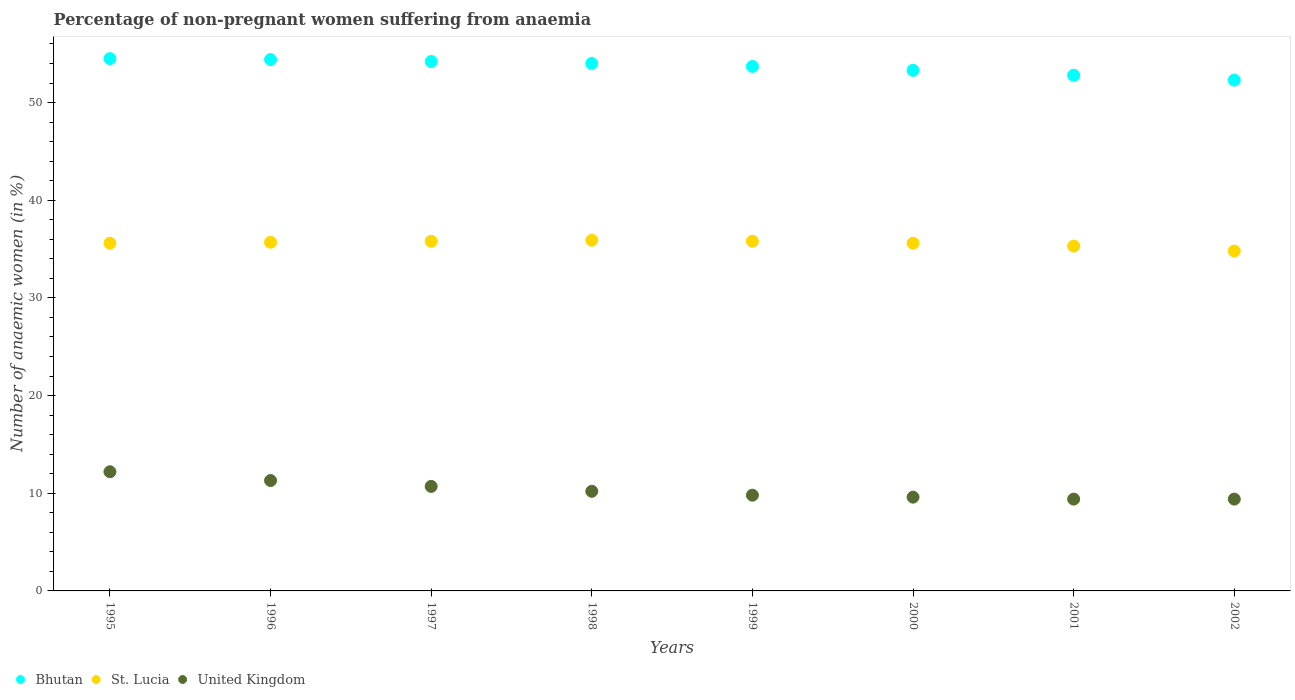What is the percentage of non-pregnant women suffering from anaemia in United Kingdom in 1998?
Your response must be concise. 10.2. Across all years, what is the maximum percentage of non-pregnant women suffering from anaemia in United Kingdom?
Your answer should be very brief. 12.2. In which year was the percentage of non-pregnant women suffering from anaemia in Bhutan maximum?
Your response must be concise. 1995. In which year was the percentage of non-pregnant women suffering from anaemia in St. Lucia minimum?
Offer a very short reply. 2002. What is the total percentage of non-pregnant women suffering from anaemia in United Kingdom in the graph?
Offer a very short reply. 82.6. What is the difference between the percentage of non-pregnant women suffering from anaemia in Bhutan in 1996 and that in 2000?
Offer a terse response. 1.1. What is the difference between the percentage of non-pregnant women suffering from anaemia in United Kingdom in 2002 and the percentage of non-pregnant women suffering from anaemia in St. Lucia in 1996?
Provide a short and direct response. -26.3. What is the average percentage of non-pregnant women suffering from anaemia in Bhutan per year?
Your response must be concise. 53.65. What is the ratio of the percentage of non-pregnant women suffering from anaemia in Bhutan in 1996 to that in 1999?
Keep it short and to the point. 1.01. Is the percentage of non-pregnant women suffering from anaemia in Bhutan in 1998 less than that in 2002?
Give a very brief answer. No. What is the difference between the highest and the second highest percentage of non-pregnant women suffering from anaemia in St. Lucia?
Make the answer very short. 0.1. What is the difference between the highest and the lowest percentage of non-pregnant women suffering from anaemia in St. Lucia?
Your answer should be very brief. 1.1. In how many years, is the percentage of non-pregnant women suffering from anaemia in St. Lucia greater than the average percentage of non-pregnant women suffering from anaemia in St. Lucia taken over all years?
Your response must be concise. 6. Does the percentage of non-pregnant women suffering from anaemia in United Kingdom monotonically increase over the years?
Give a very brief answer. No. Is the percentage of non-pregnant women suffering from anaemia in Bhutan strictly less than the percentage of non-pregnant women suffering from anaemia in St. Lucia over the years?
Make the answer very short. No. How many dotlines are there?
Provide a short and direct response. 3. How many years are there in the graph?
Your response must be concise. 8. What is the difference between two consecutive major ticks on the Y-axis?
Provide a succinct answer. 10. Are the values on the major ticks of Y-axis written in scientific E-notation?
Offer a terse response. No. Does the graph contain grids?
Ensure brevity in your answer.  No. How many legend labels are there?
Ensure brevity in your answer.  3. What is the title of the graph?
Your response must be concise. Percentage of non-pregnant women suffering from anaemia. What is the label or title of the Y-axis?
Your response must be concise. Number of anaemic women (in %). What is the Number of anaemic women (in %) in Bhutan in 1995?
Your answer should be compact. 54.5. What is the Number of anaemic women (in %) in St. Lucia in 1995?
Offer a terse response. 35.6. What is the Number of anaemic women (in %) of Bhutan in 1996?
Ensure brevity in your answer.  54.4. What is the Number of anaemic women (in %) of St. Lucia in 1996?
Ensure brevity in your answer.  35.7. What is the Number of anaemic women (in %) of Bhutan in 1997?
Your answer should be very brief. 54.2. What is the Number of anaemic women (in %) of St. Lucia in 1997?
Give a very brief answer. 35.8. What is the Number of anaemic women (in %) of St. Lucia in 1998?
Make the answer very short. 35.9. What is the Number of anaemic women (in %) of Bhutan in 1999?
Your response must be concise. 53.7. What is the Number of anaemic women (in %) of St. Lucia in 1999?
Your answer should be very brief. 35.8. What is the Number of anaemic women (in %) in United Kingdom in 1999?
Give a very brief answer. 9.8. What is the Number of anaemic women (in %) of Bhutan in 2000?
Offer a very short reply. 53.3. What is the Number of anaemic women (in %) of St. Lucia in 2000?
Provide a short and direct response. 35.6. What is the Number of anaemic women (in %) of United Kingdom in 2000?
Ensure brevity in your answer.  9.6. What is the Number of anaemic women (in %) in Bhutan in 2001?
Ensure brevity in your answer.  52.8. What is the Number of anaemic women (in %) of St. Lucia in 2001?
Provide a short and direct response. 35.3. What is the Number of anaemic women (in %) of Bhutan in 2002?
Your answer should be compact. 52.3. What is the Number of anaemic women (in %) of St. Lucia in 2002?
Give a very brief answer. 34.8. Across all years, what is the maximum Number of anaemic women (in %) of Bhutan?
Keep it short and to the point. 54.5. Across all years, what is the maximum Number of anaemic women (in %) of St. Lucia?
Ensure brevity in your answer.  35.9. Across all years, what is the maximum Number of anaemic women (in %) in United Kingdom?
Keep it short and to the point. 12.2. Across all years, what is the minimum Number of anaemic women (in %) in Bhutan?
Your answer should be very brief. 52.3. Across all years, what is the minimum Number of anaemic women (in %) of St. Lucia?
Make the answer very short. 34.8. What is the total Number of anaemic women (in %) in Bhutan in the graph?
Provide a short and direct response. 429.2. What is the total Number of anaemic women (in %) in St. Lucia in the graph?
Keep it short and to the point. 284.5. What is the total Number of anaemic women (in %) of United Kingdom in the graph?
Ensure brevity in your answer.  82.6. What is the difference between the Number of anaemic women (in %) in St. Lucia in 1995 and that in 1996?
Ensure brevity in your answer.  -0.1. What is the difference between the Number of anaemic women (in %) in United Kingdom in 1995 and that in 1996?
Your answer should be compact. 0.9. What is the difference between the Number of anaemic women (in %) of St. Lucia in 1995 and that in 1997?
Offer a very short reply. -0.2. What is the difference between the Number of anaemic women (in %) of United Kingdom in 1995 and that in 1997?
Keep it short and to the point. 1.5. What is the difference between the Number of anaemic women (in %) in Bhutan in 1995 and that in 1998?
Offer a terse response. 0.5. What is the difference between the Number of anaemic women (in %) in St. Lucia in 1995 and that in 1998?
Keep it short and to the point. -0.3. What is the difference between the Number of anaemic women (in %) in Bhutan in 1995 and that in 1999?
Offer a very short reply. 0.8. What is the difference between the Number of anaemic women (in %) of St. Lucia in 1995 and that in 1999?
Provide a succinct answer. -0.2. What is the difference between the Number of anaemic women (in %) of Bhutan in 1995 and that in 2000?
Give a very brief answer. 1.2. What is the difference between the Number of anaemic women (in %) in St. Lucia in 1995 and that in 2000?
Your response must be concise. 0. What is the difference between the Number of anaemic women (in %) in United Kingdom in 1995 and that in 2000?
Keep it short and to the point. 2.6. What is the difference between the Number of anaemic women (in %) of Bhutan in 1995 and that in 2001?
Offer a terse response. 1.7. What is the difference between the Number of anaemic women (in %) in St. Lucia in 1995 and that in 2001?
Provide a short and direct response. 0.3. What is the difference between the Number of anaemic women (in %) of United Kingdom in 1995 and that in 2001?
Ensure brevity in your answer.  2.8. What is the difference between the Number of anaemic women (in %) in Bhutan in 1995 and that in 2002?
Keep it short and to the point. 2.2. What is the difference between the Number of anaemic women (in %) of St. Lucia in 1996 and that in 1997?
Make the answer very short. -0.1. What is the difference between the Number of anaemic women (in %) of Bhutan in 1996 and that in 1998?
Make the answer very short. 0.4. What is the difference between the Number of anaemic women (in %) in St. Lucia in 1996 and that in 1998?
Your response must be concise. -0.2. What is the difference between the Number of anaemic women (in %) of Bhutan in 1996 and that in 1999?
Provide a succinct answer. 0.7. What is the difference between the Number of anaemic women (in %) of United Kingdom in 1996 and that in 1999?
Offer a terse response. 1.5. What is the difference between the Number of anaemic women (in %) of United Kingdom in 1996 and that in 2000?
Keep it short and to the point. 1.7. What is the difference between the Number of anaemic women (in %) of Bhutan in 1996 and that in 2001?
Give a very brief answer. 1.6. What is the difference between the Number of anaemic women (in %) in St. Lucia in 1996 and that in 2001?
Keep it short and to the point. 0.4. What is the difference between the Number of anaemic women (in %) of United Kingdom in 1996 and that in 2002?
Ensure brevity in your answer.  1.9. What is the difference between the Number of anaemic women (in %) in United Kingdom in 1997 and that in 1998?
Offer a very short reply. 0.5. What is the difference between the Number of anaemic women (in %) in St. Lucia in 1997 and that in 1999?
Make the answer very short. 0. What is the difference between the Number of anaemic women (in %) in United Kingdom in 1997 and that in 1999?
Give a very brief answer. 0.9. What is the difference between the Number of anaemic women (in %) in Bhutan in 1997 and that in 2000?
Give a very brief answer. 0.9. What is the difference between the Number of anaemic women (in %) of United Kingdom in 1997 and that in 2001?
Provide a short and direct response. 1.3. What is the difference between the Number of anaemic women (in %) in Bhutan in 1997 and that in 2002?
Offer a terse response. 1.9. What is the difference between the Number of anaemic women (in %) of United Kingdom in 1997 and that in 2002?
Offer a terse response. 1.3. What is the difference between the Number of anaemic women (in %) of United Kingdom in 1998 and that in 2001?
Your answer should be compact. 0.8. What is the difference between the Number of anaemic women (in %) of Bhutan in 1999 and that in 2000?
Provide a short and direct response. 0.4. What is the difference between the Number of anaemic women (in %) of St. Lucia in 1999 and that in 2000?
Your response must be concise. 0.2. What is the difference between the Number of anaemic women (in %) of United Kingdom in 1999 and that in 2000?
Your answer should be very brief. 0.2. What is the difference between the Number of anaemic women (in %) of United Kingdom in 1999 and that in 2002?
Provide a succinct answer. 0.4. What is the difference between the Number of anaemic women (in %) of Bhutan in 2000 and that in 2001?
Keep it short and to the point. 0.5. What is the difference between the Number of anaemic women (in %) of St. Lucia in 2000 and that in 2001?
Provide a short and direct response. 0.3. What is the difference between the Number of anaemic women (in %) of United Kingdom in 2000 and that in 2001?
Offer a terse response. 0.2. What is the difference between the Number of anaemic women (in %) of United Kingdom in 2000 and that in 2002?
Your answer should be very brief. 0.2. What is the difference between the Number of anaemic women (in %) of St. Lucia in 2001 and that in 2002?
Your answer should be very brief. 0.5. What is the difference between the Number of anaemic women (in %) of United Kingdom in 2001 and that in 2002?
Your answer should be compact. 0. What is the difference between the Number of anaemic women (in %) of Bhutan in 1995 and the Number of anaemic women (in %) of United Kingdom in 1996?
Give a very brief answer. 43.2. What is the difference between the Number of anaemic women (in %) in St. Lucia in 1995 and the Number of anaemic women (in %) in United Kingdom in 1996?
Your answer should be very brief. 24.3. What is the difference between the Number of anaemic women (in %) in Bhutan in 1995 and the Number of anaemic women (in %) in St. Lucia in 1997?
Offer a terse response. 18.7. What is the difference between the Number of anaemic women (in %) of Bhutan in 1995 and the Number of anaemic women (in %) of United Kingdom in 1997?
Provide a short and direct response. 43.8. What is the difference between the Number of anaemic women (in %) of St. Lucia in 1995 and the Number of anaemic women (in %) of United Kingdom in 1997?
Provide a short and direct response. 24.9. What is the difference between the Number of anaemic women (in %) of Bhutan in 1995 and the Number of anaemic women (in %) of United Kingdom in 1998?
Your response must be concise. 44.3. What is the difference between the Number of anaemic women (in %) in St. Lucia in 1995 and the Number of anaemic women (in %) in United Kingdom in 1998?
Give a very brief answer. 25.4. What is the difference between the Number of anaemic women (in %) of Bhutan in 1995 and the Number of anaemic women (in %) of St. Lucia in 1999?
Ensure brevity in your answer.  18.7. What is the difference between the Number of anaemic women (in %) in Bhutan in 1995 and the Number of anaemic women (in %) in United Kingdom in 1999?
Ensure brevity in your answer.  44.7. What is the difference between the Number of anaemic women (in %) of St. Lucia in 1995 and the Number of anaemic women (in %) of United Kingdom in 1999?
Ensure brevity in your answer.  25.8. What is the difference between the Number of anaemic women (in %) in Bhutan in 1995 and the Number of anaemic women (in %) in United Kingdom in 2000?
Your response must be concise. 44.9. What is the difference between the Number of anaemic women (in %) in Bhutan in 1995 and the Number of anaemic women (in %) in United Kingdom in 2001?
Offer a terse response. 45.1. What is the difference between the Number of anaemic women (in %) in St. Lucia in 1995 and the Number of anaemic women (in %) in United Kingdom in 2001?
Make the answer very short. 26.2. What is the difference between the Number of anaemic women (in %) of Bhutan in 1995 and the Number of anaemic women (in %) of United Kingdom in 2002?
Provide a succinct answer. 45.1. What is the difference between the Number of anaemic women (in %) of St. Lucia in 1995 and the Number of anaemic women (in %) of United Kingdom in 2002?
Provide a short and direct response. 26.2. What is the difference between the Number of anaemic women (in %) of Bhutan in 1996 and the Number of anaemic women (in %) of United Kingdom in 1997?
Your answer should be very brief. 43.7. What is the difference between the Number of anaemic women (in %) in St. Lucia in 1996 and the Number of anaemic women (in %) in United Kingdom in 1997?
Offer a terse response. 25. What is the difference between the Number of anaemic women (in %) in Bhutan in 1996 and the Number of anaemic women (in %) in United Kingdom in 1998?
Ensure brevity in your answer.  44.2. What is the difference between the Number of anaemic women (in %) in St. Lucia in 1996 and the Number of anaemic women (in %) in United Kingdom in 1998?
Your response must be concise. 25.5. What is the difference between the Number of anaemic women (in %) of Bhutan in 1996 and the Number of anaemic women (in %) of St. Lucia in 1999?
Your answer should be compact. 18.6. What is the difference between the Number of anaemic women (in %) of Bhutan in 1996 and the Number of anaemic women (in %) of United Kingdom in 1999?
Make the answer very short. 44.6. What is the difference between the Number of anaemic women (in %) in St. Lucia in 1996 and the Number of anaemic women (in %) in United Kingdom in 1999?
Keep it short and to the point. 25.9. What is the difference between the Number of anaemic women (in %) in Bhutan in 1996 and the Number of anaemic women (in %) in St. Lucia in 2000?
Ensure brevity in your answer.  18.8. What is the difference between the Number of anaemic women (in %) of Bhutan in 1996 and the Number of anaemic women (in %) of United Kingdom in 2000?
Offer a terse response. 44.8. What is the difference between the Number of anaemic women (in %) of St. Lucia in 1996 and the Number of anaemic women (in %) of United Kingdom in 2000?
Provide a short and direct response. 26.1. What is the difference between the Number of anaemic women (in %) in Bhutan in 1996 and the Number of anaemic women (in %) in United Kingdom in 2001?
Provide a short and direct response. 45. What is the difference between the Number of anaemic women (in %) in St. Lucia in 1996 and the Number of anaemic women (in %) in United Kingdom in 2001?
Your response must be concise. 26.3. What is the difference between the Number of anaemic women (in %) in Bhutan in 1996 and the Number of anaemic women (in %) in St. Lucia in 2002?
Your answer should be compact. 19.6. What is the difference between the Number of anaemic women (in %) in St. Lucia in 1996 and the Number of anaemic women (in %) in United Kingdom in 2002?
Provide a succinct answer. 26.3. What is the difference between the Number of anaemic women (in %) in Bhutan in 1997 and the Number of anaemic women (in %) in United Kingdom in 1998?
Your response must be concise. 44. What is the difference between the Number of anaemic women (in %) of St. Lucia in 1997 and the Number of anaemic women (in %) of United Kingdom in 1998?
Make the answer very short. 25.6. What is the difference between the Number of anaemic women (in %) in Bhutan in 1997 and the Number of anaemic women (in %) in St. Lucia in 1999?
Give a very brief answer. 18.4. What is the difference between the Number of anaemic women (in %) of Bhutan in 1997 and the Number of anaemic women (in %) of United Kingdom in 1999?
Provide a short and direct response. 44.4. What is the difference between the Number of anaemic women (in %) of St. Lucia in 1997 and the Number of anaemic women (in %) of United Kingdom in 1999?
Offer a terse response. 26. What is the difference between the Number of anaemic women (in %) in Bhutan in 1997 and the Number of anaemic women (in %) in St. Lucia in 2000?
Make the answer very short. 18.6. What is the difference between the Number of anaemic women (in %) of Bhutan in 1997 and the Number of anaemic women (in %) of United Kingdom in 2000?
Your response must be concise. 44.6. What is the difference between the Number of anaemic women (in %) of St. Lucia in 1997 and the Number of anaemic women (in %) of United Kingdom in 2000?
Keep it short and to the point. 26.2. What is the difference between the Number of anaemic women (in %) in Bhutan in 1997 and the Number of anaemic women (in %) in St. Lucia in 2001?
Ensure brevity in your answer.  18.9. What is the difference between the Number of anaemic women (in %) of Bhutan in 1997 and the Number of anaemic women (in %) of United Kingdom in 2001?
Make the answer very short. 44.8. What is the difference between the Number of anaemic women (in %) in St. Lucia in 1997 and the Number of anaemic women (in %) in United Kingdom in 2001?
Give a very brief answer. 26.4. What is the difference between the Number of anaemic women (in %) of Bhutan in 1997 and the Number of anaemic women (in %) of United Kingdom in 2002?
Your answer should be very brief. 44.8. What is the difference between the Number of anaemic women (in %) in St. Lucia in 1997 and the Number of anaemic women (in %) in United Kingdom in 2002?
Ensure brevity in your answer.  26.4. What is the difference between the Number of anaemic women (in %) in Bhutan in 1998 and the Number of anaemic women (in %) in United Kingdom in 1999?
Provide a succinct answer. 44.2. What is the difference between the Number of anaemic women (in %) in St. Lucia in 1998 and the Number of anaemic women (in %) in United Kingdom in 1999?
Keep it short and to the point. 26.1. What is the difference between the Number of anaemic women (in %) in Bhutan in 1998 and the Number of anaemic women (in %) in United Kingdom in 2000?
Your answer should be very brief. 44.4. What is the difference between the Number of anaemic women (in %) in St. Lucia in 1998 and the Number of anaemic women (in %) in United Kingdom in 2000?
Keep it short and to the point. 26.3. What is the difference between the Number of anaemic women (in %) of Bhutan in 1998 and the Number of anaemic women (in %) of United Kingdom in 2001?
Your response must be concise. 44.6. What is the difference between the Number of anaemic women (in %) in Bhutan in 1998 and the Number of anaemic women (in %) in United Kingdom in 2002?
Offer a terse response. 44.6. What is the difference between the Number of anaemic women (in %) of Bhutan in 1999 and the Number of anaemic women (in %) of United Kingdom in 2000?
Make the answer very short. 44.1. What is the difference between the Number of anaemic women (in %) of St. Lucia in 1999 and the Number of anaemic women (in %) of United Kingdom in 2000?
Provide a succinct answer. 26.2. What is the difference between the Number of anaemic women (in %) of Bhutan in 1999 and the Number of anaemic women (in %) of St. Lucia in 2001?
Ensure brevity in your answer.  18.4. What is the difference between the Number of anaemic women (in %) of Bhutan in 1999 and the Number of anaemic women (in %) of United Kingdom in 2001?
Make the answer very short. 44.3. What is the difference between the Number of anaemic women (in %) of St. Lucia in 1999 and the Number of anaemic women (in %) of United Kingdom in 2001?
Offer a terse response. 26.4. What is the difference between the Number of anaemic women (in %) of Bhutan in 1999 and the Number of anaemic women (in %) of United Kingdom in 2002?
Your answer should be very brief. 44.3. What is the difference between the Number of anaemic women (in %) in St. Lucia in 1999 and the Number of anaemic women (in %) in United Kingdom in 2002?
Your answer should be very brief. 26.4. What is the difference between the Number of anaemic women (in %) in Bhutan in 2000 and the Number of anaemic women (in %) in St. Lucia in 2001?
Provide a succinct answer. 18. What is the difference between the Number of anaemic women (in %) in Bhutan in 2000 and the Number of anaemic women (in %) in United Kingdom in 2001?
Keep it short and to the point. 43.9. What is the difference between the Number of anaemic women (in %) of St. Lucia in 2000 and the Number of anaemic women (in %) of United Kingdom in 2001?
Make the answer very short. 26.2. What is the difference between the Number of anaemic women (in %) in Bhutan in 2000 and the Number of anaemic women (in %) in United Kingdom in 2002?
Provide a succinct answer. 43.9. What is the difference between the Number of anaemic women (in %) in St. Lucia in 2000 and the Number of anaemic women (in %) in United Kingdom in 2002?
Make the answer very short. 26.2. What is the difference between the Number of anaemic women (in %) in Bhutan in 2001 and the Number of anaemic women (in %) in United Kingdom in 2002?
Provide a short and direct response. 43.4. What is the difference between the Number of anaemic women (in %) of St. Lucia in 2001 and the Number of anaemic women (in %) of United Kingdom in 2002?
Your response must be concise. 25.9. What is the average Number of anaemic women (in %) in Bhutan per year?
Ensure brevity in your answer.  53.65. What is the average Number of anaemic women (in %) in St. Lucia per year?
Give a very brief answer. 35.56. What is the average Number of anaemic women (in %) in United Kingdom per year?
Your response must be concise. 10.32. In the year 1995, what is the difference between the Number of anaemic women (in %) of Bhutan and Number of anaemic women (in %) of St. Lucia?
Make the answer very short. 18.9. In the year 1995, what is the difference between the Number of anaemic women (in %) of Bhutan and Number of anaemic women (in %) of United Kingdom?
Give a very brief answer. 42.3. In the year 1995, what is the difference between the Number of anaemic women (in %) of St. Lucia and Number of anaemic women (in %) of United Kingdom?
Make the answer very short. 23.4. In the year 1996, what is the difference between the Number of anaemic women (in %) in Bhutan and Number of anaemic women (in %) in United Kingdom?
Provide a short and direct response. 43.1. In the year 1996, what is the difference between the Number of anaemic women (in %) in St. Lucia and Number of anaemic women (in %) in United Kingdom?
Your answer should be very brief. 24.4. In the year 1997, what is the difference between the Number of anaemic women (in %) in Bhutan and Number of anaemic women (in %) in United Kingdom?
Your answer should be very brief. 43.5. In the year 1997, what is the difference between the Number of anaemic women (in %) in St. Lucia and Number of anaemic women (in %) in United Kingdom?
Keep it short and to the point. 25.1. In the year 1998, what is the difference between the Number of anaemic women (in %) in Bhutan and Number of anaemic women (in %) in United Kingdom?
Give a very brief answer. 43.8. In the year 1998, what is the difference between the Number of anaemic women (in %) in St. Lucia and Number of anaemic women (in %) in United Kingdom?
Make the answer very short. 25.7. In the year 1999, what is the difference between the Number of anaemic women (in %) of Bhutan and Number of anaemic women (in %) of St. Lucia?
Give a very brief answer. 17.9. In the year 1999, what is the difference between the Number of anaemic women (in %) of Bhutan and Number of anaemic women (in %) of United Kingdom?
Make the answer very short. 43.9. In the year 2000, what is the difference between the Number of anaemic women (in %) of Bhutan and Number of anaemic women (in %) of St. Lucia?
Offer a very short reply. 17.7. In the year 2000, what is the difference between the Number of anaemic women (in %) in Bhutan and Number of anaemic women (in %) in United Kingdom?
Your answer should be compact. 43.7. In the year 2000, what is the difference between the Number of anaemic women (in %) of St. Lucia and Number of anaemic women (in %) of United Kingdom?
Ensure brevity in your answer.  26. In the year 2001, what is the difference between the Number of anaemic women (in %) of Bhutan and Number of anaemic women (in %) of United Kingdom?
Your answer should be compact. 43.4. In the year 2001, what is the difference between the Number of anaemic women (in %) in St. Lucia and Number of anaemic women (in %) in United Kingdom?
Provide a succinct answer. 25.9. In the year 2002, what is the difference between the Number of anaemic women (in %) in Bhutan and Number of anaemic women (in %) in St. Lucia?
Ensure brevity in your answer.  17.5. In the year 2002, what is the difference between the Number of anaemic women (in %) in Bhutan and Number of anaemic women (in %) in United Kingdom?
Make the answer very short. 42.9. In the year 2002, what is the difference between the Number of anaemic women (in %) of St. Lucia and Number of anaemic women (in %) of United Kingdom?
Provide a succinct answer. 25.4. What is the ratio of the Number of anaemic women (in %) of St. Lucia in 1995 to that in 1996?
Your answer should be compact. 1. What is the ratio of the Number of anaemic women (in %) in United Kingdom in 1995 to that in 1996?
Ensure brevity in your answer.  1.08. What is the ratio of the Number of anaemic women (in %) in Bhutan in 1995 to that in 1997?
Make the answer very short. 1.01. What is the ratio of the Number of anaemic women (in %) in St. Lucia in 1995 to that in 1997?
Your response must be concise. 0.99. What is the ratio of the Number of anaemic women (in %) in United Kingdom in 1995 to that in 1997?
Ensure brevity in your answer.  1.14. What is the ratio of the Number of anaemic women (in %) of Bhutan in 1995 to that in 1998?
Offer a terse response. 1.01. What is the ratio of the Number of anaemic women (in %) in United Kingdom in 1995 to that in 1998?
Make the answer very short. 1.2. What is the ratio of the Number of anaemic women (in %) of Bhutan in 1995 to that in 1999?
Offer a terse response. 1.01. What is the ratio of the Number of anaemic women (in %) in St. Lucia in 1995 to that in 1999?
Offer a very short reply. 0.99. What is the ratio of the Number of anaemic women (in %) of United Kingdom in 1995 to that in 1999?
Give a very brief answer. 1.24. What is the ratio of the Number of anaemic women (in %) of Bhutan in 1995 to that in 2000?
Keep it short and to the point. 1.02. What is the ratio of the Number of anaemic women (in %) in St. Lucia in 1995 to that in 2000?
Give a very brief answer. 1. What is the ratio of the Number of anaemic women (in %) of United Kingdom in 1995 to that in 2000?
Your answer should be very brief. 1.27. What is the ratio of the Number of anaemic women (in %) of Bhutan in 1995 to that in 2001?
Ensure brevity in your answer.  1.03. What is the ratio of the Number of anaemic women (in %) of St. Lucia in 1995 to that in 2001?
Offer a terse response. 1.01. What is the ratio of the Number of anaemic women (in %) in United Kingdom in 1995 to that in 2001?
Provide a short and direct response. 1.3. What is the ratio of the Number of anaemic women (in %) in Bhutan in 1995 to that in 2002?
Provide a short and direct response. 1.04. What is the ratio of the Number of anaemic women (in %) in United Kingdom in 1995 to that in 2002?
Make the answer very short. 1.3. What is the ratio of the Number of anaemic women (in %) of Bhutan in 1996 to that in 1997?
Your answer should be compact. 1. What is the ratio of the Number of anaemic women (in %) of St. Lucia in 1996 to that in 1997?
Your answer should be compact. 1. What is the ratio of the Number of anaemic women (in %) of United Kingdom in 1996 to that in 1997?
Make the answer very short. 1.06. What is the ratio of the Number of anaemic women (in %) in Bhutan in 1996 to that in 1998?
Offer a terse response. 1.01. What is the ratio of the Number of anaemic women (in %) of United Kingdom in 1996 to that in 1998?
Provide a succinct answer. 1.11. What is the ratio of the Number of anaemic women (in %) of Bhutan in 1996 to that in 1999?
Offer a terse response. 1.01. What is the ratio of the Number of anaemic women (in %) in St. Lucia in 1996 to that in 1999?
Ensure brevity in your answer.  1. What is the ratio of the Number of anaemic women (in %) of United Kingdom in 1996 to that in 1999?
Make the answer very short. 1.15. What is the ratio of the Number of anaemic women (in %) in Bhutan in 1996 to that in 2000?
Offer a very short reply. 1.02. What is the ratio of the Number of anaemic women (in %) of St. Lucia in 1996 to that in 2000?
Your answer should be compact. 1. What is the ratio of the Number of anaemic women (in %) of United Kingdom in 1996 to that in 2000?
Provide a short and direct response. 1.18. What is the ratio of the Number of anaemic women (in %) in Bhutan in 1996 to that in 2001?
Your response must be concise. 1.03. What is the ratio of the Number of anaemic women (in %) of St. Lucia in 1996 to that in 2001?
Your answer should be very brief. 1.01. What is the ratio of the Number of anaemic women (in %) in United Kingdom in 1996 to that in 2001?
Provide a succinct answer. 1.2. What is the ratio of the Number of anaemic women (in %) in Bhutan in 1996 to that in 2002?
Give a very brief answer. 1.04. What is the ratio of the Number of anaemic women (in %) in St. Lucia in 1996 to that in 2002?
Keep it short and to the point. 1.03. What is the ratio of the Number of anaemic women (in %) in United Kingdom in 1996 to that in 2002?
Your response must be concise. 1.2. What is the ratio of the Number of anaemic women (in %) in St. Lucia in 1997 to that in 1998?
Offer a terse response. 1. What is the ratio of the Number of anaemic women (in %) of United Kingdom in 1997 to that in 1998?
Your response must be concise. 1.05. What is the ratio of the Number of anaemic women (in %) in Bhutan in 1997 to that in 1999?
Give a very brief answer. 1.01. What is the ratio of the Number of anaemic women (in %) in United Kingdom in 1997 to that in 1999?
Give a very brief answer. 1.09. What is the ratio of the Number of anaemic women (in %) in Bhutan in 1997 to that in 2000?
Provide a succinct answer. 1.02. What is the ratio of the Number of anaemic women (in %) of St. Lucia in 1997 to that in 2000?
Offer a very short reply. 1.01. What is the ratio of the Number of anaemic women (in %) in United Kingdom in 1997 to that in 2000?
Your answer should be compact. 1.11. What is the ratio of the Number of anaemic women (in %) of Bhutan in 1997 to that in 2001?
Provide a succinct answer. 1.03. What is the ratio of the Number of anaemic women (in %) in St. Lucia in 1997 to that in 2001?
Give a very brief answer. 1.01. What is the ratio of the Number of anaemic women (in %) in United Kingdom in 1997 to that in 2001?
Keep it short and to the point. 1.14. What is the ratio of the Number of anaemic women (in %) of Bhutan in 1997 to that in 2002?
Keep it short and to the point. 1.04. What is the ratio of the Number of anaemic women (in %) in St. Lucia in 1997 to that in 2002?
Offer a very short reply. 1.03. What is the ratio of the Number of anaemic women (in %) in United Kingdom in 1997 to that in 2002?
Provide a succinct answer. 1.14. What is the ratio of the Number of anaemic women (in %) in Bhutan in 1998 to that in 1999?
Offer a terse response. 1.01. What is the ratio of the Number of anaemic women (in %) of St. Lucia in 1998 to that in 1999?
Give a very brief answer. 1. What is the ratio of the Number of anaemic women (in %) of United Kingdom in 1998 to that in 1999?
Your answer should be compact. 1.04. What is the ratio of the Number of anaemic women (in %) in Bhutan in 1998 to that in 2000?
Your answer should be very brief. 1.01. What is the ratio of the Number of anaemic women (in %) of St. Lucia in 1998 to that in 2000?
Your response must be concise. 1.01. What is the ratio of the Number of anaemic women (in %) in United Kingdom in 1998 to that in 2000?
Provide a succinct answer. 1.06. What is the ratio of the Number of anaemic women (in %) in Bhutan in 1998 to that in 2001?
Provide a succinct answer. 1.02. What is the ratio of the Number of anaemic women (in %) of United Kingdom in 1998 to that in 2001?
Offer a very short reply. 1.09. What is the ratio of the Number of anaemic women (in %) of Bhutan in 1998 to that in 2002?
Your answer should be very brief. 1.03. What is the ratio of the Number of anaemic women (in %) in St. Lucia in 1998 to that in 2002?
Keep it short and to the point. 1.03. What is the ratio of the Number of anaemic women (in %) of United Kingdom in 1998 to that in 2002?
Offer a very short reply. 1.09. What is the ratio of the Number of anaemic women (in %) in Bhutan in 1999 to that in 2000?
Provide a short and direct response. 1.01. What is the ratio of the Number of anaemic women (in %) of St. Lucia in 1999 to that in 2000?
Provide a succinct answer. 1.01. What is the ratio of the Number of anaemic women (in %) in United Kingdom in 1999 to that in 2000?
Offer a terse response. 1.02. What is the ratio of the Number of anaemic women (in %) in St. Lucia in 1999 to that in 2001?
Keep it short and to the point. 1.01. What is the ratio of the Number of anaemic women (in %) in United Kingdom in 1999 to that in 2001?
Offer a terse response. 1.04. What is the ratio of the Number of anaemic women (in %) of Bhutan in 1999 to that in 2002?
Make the answer very short. 1.03. What is the ratio of the Number of anaemic women (in %) in St. Lucia in 1999 to that in 2002?
Your response must be concise. 1.03. What is the ratio of the Number of anaemic women (in %) in United Kingdom in 1999 to that in 2002?
Your answer should be very brief. 1.04. What is the ratio of the Number of anaemic women (in %) of Bhutan in 2000 to that in 2001?
Ensure brevity in your answer.  1.01. What is the ratio of the Number of anaemic women (in %) of St. Lucia in 2000 to that in 2001?
Give a very brief answer. 1.01. What is the ratio of the Number of anaemic women (in %) in United Kingdom in 2000 to that in 2001?
Your response must be concise. 1.02. What is the ratio of the Number of anaemic women (in %) of Bhutan in 2000 to that in 2002?
Offer a terse response. 1.02. What is the ratio of the Number of anaemic women (in %) of St. Lucia in 2000 to that in 2002?
Provide a short and direct response. 1.02. What is the ratio of the Number of anaemic women (in %) of United Kingdom in 2000 to that in 2002?
Your response must be concise. 1.02. What is the ratio of the Number of anaemic women (in %) in Bhutan in 2001 to that in 2002?
Give a very brief answer. 1.01. What is the ratio of the Number of anaemic women (in %) of St. Lucia in 2001 to that in 2002?
Provide a succinct answer. 1.01. What is the difference between the highest and the second highest Number of anaemic women (in %) in Bhutan?
Offer a terse response. 0.1. What is the difference between the highest and the second highest Number of anaemic women (in %) of St. Lucia?
Offer a terse response. 0.1. What is the difference between the highest and the second highest Number of anaemic women (in %) of United Kingdom?
Make the answer very short. 0.9. What is the difference between the highest and the lowest Number of anaemic women (in %) in Bhutan?
Offer a very short reply. 2.2. What is the difference between the highest and the lowest Number of anaemic women (in %) in St. Lucia?
Keep it short and to the point. 1.1. 